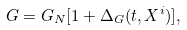<formula> <loc_0><loc_0><loc_500><loc_500>G = G _ { N } [ 1 + \Delta _ { G } ( t , X ^ { i } ) ] ,</formula> 